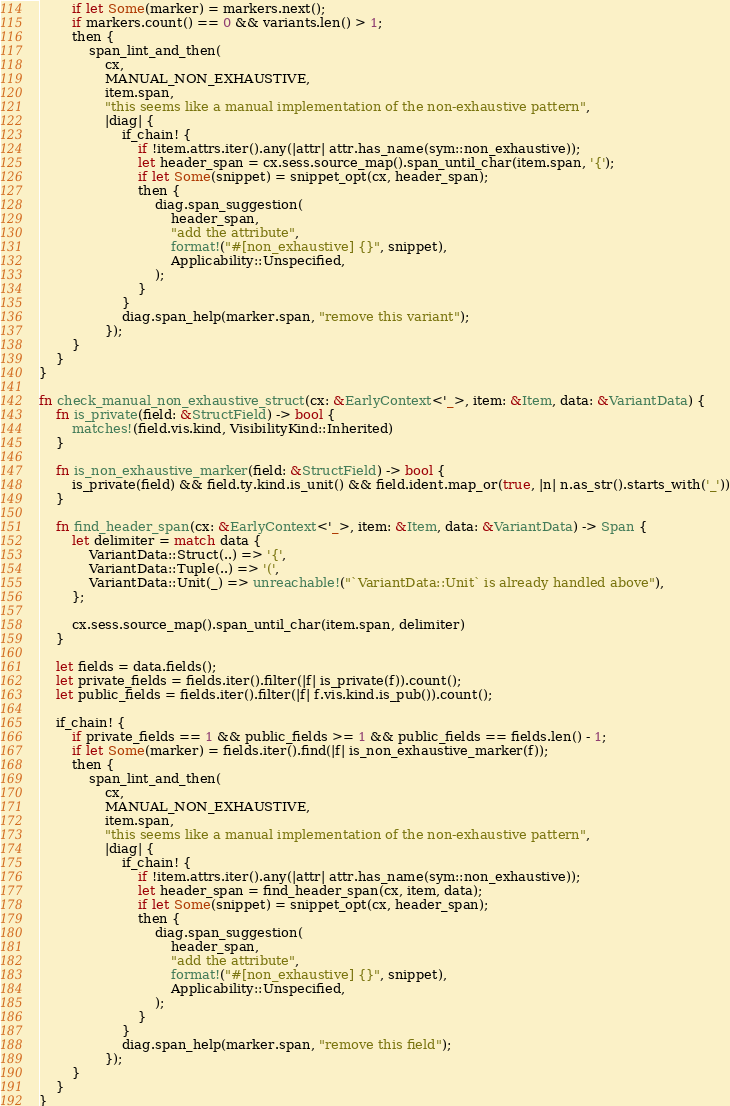<code> <loc_0><loc_0><loc_500><loc_500><_Rust_>        if let Some(marker) = markers.next();
        if markers.count() == 0 && variants.len() > 1;
        then {
            span_lint_and_then(
                cx,
                MANUAL_NON_EXHAUSTIVE,
                item.span,
                "this seems like a manual implementation of the non-exhaustive pattern",
                |diag| {
                    if_chain! {
                        if !item.attrs.iter().any(|attr| attr.has_name(sym::non_exhaustive));
                        let header_span = cx.sess.source_map().span_until_char(item.span, '{');
                        if let Some(snippet) = snippet_opt(cx, header_span);
                        then {
                            diag.span_suggestion(
                                header_span,
                                "add the attribute",
                                format!("#[non_exhaustive] {}", snippet),
                                Applicability::Unspecified,
                            );
                        }
                    }
                    diag.span_help(marker.span, "remove this variant");
                });
        }
    }
}

fn check_manual_non_exhaustive_struct(cx: &EarlyContext<'_>, item: &Item, data: &VariantData) {
    fn is_private(field: &StructField) -> bool {
        matches!(field.vis.kind, VisibilityKind::Inherited)
    }

    fn is_non_exhaustive_marker(field: &StructField) -> bool {
        is_private(field) && field.ty.kind.is_unit() && field.ident.map_or(true, |n| n.as_str().starts_with('_'))
    }

    fn find_header_span(cx: &EarlyContext<'_>, item: &Item, data: &VariantData) -> Span {
        let delimiter = match data {
            VariantData::Struct(..) => '{',
            VariantData::Tuple(..) => '(',
            VariantData::Unit(_) => unreachable!("`VariantData::Unit` is already handled above"),
        };

        cx.sess.source_map().span_until_char(item.span, delimiter)
    }

    let fields = data.fields();
    let private_fields = fields.iter().filter(|f| is_private(f)).count();
    let public_fields = fields.iter().filter(|f| f.vis.kind.is_pub()).count();

    if_chain! {
        if private_fields == 1 && public_fields >= 1 && public_fields == fields.len() - 1;
        if let Some(marker) = fields.iter().find(|f| is_non_exhaustive_marker(f));
        then {
            span_lint_and_then(
                cx,
                MANUAL_NON_EXHAUSTIVE,
                item.span,
                "this seems like a manual implementation of the non-exhaustive pattern",
                |diag| {
                    if_chain! {
                        if !item.attrs.iter().any(|attr| attr.has_name(sym::non_exhaustive));
                        let header_span = find_header_span(cx, item, data);
                        if let Some(snippet) = snippet_opt(cx, header_span);
                        then {
                            diag.span_suggestion(
                                header_span,
                                "add the attribute",
                                format!("#[non_exhaustive] {}", snippet),
                                Applicability::Unspecified,
                            );
                        }
                    }
                    diag.span_help(marker.span, "remove this field");
                });
        }
    }
}
</code> 